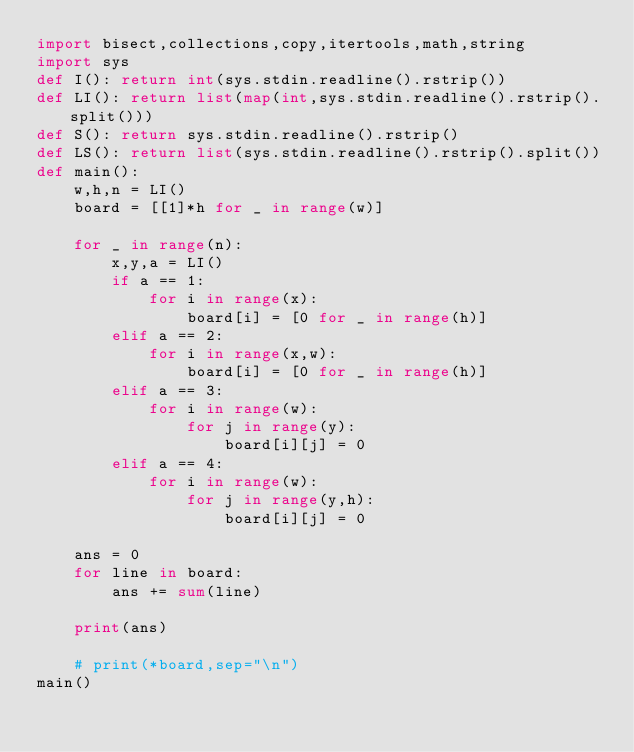<code> <loc_0><loc_0><loc_500><loc_500><_Python_>import bisect,collections,copy,itertools,math,string
import sys
def I(): return int(sys.stdin.readline().rstrip())
def LI(): return list(map(int,sys.stdin.readline().rstrip().split()))
def S(): return sys.stdin.readline().rstrip()
def LS(): return list(sys.stdin.readline().rstrip().split())
def main():
    w,h,n = LI()
    board = [[1]*h for _ in range(w)]

    for _ in range(n):
        x,y,a = LI()
        if a == 1:
            for i in range(x):
                board[i] = [0 for _ in range(h)]
        elif a == 2:
            for i in range(x,w):
                board[i] = [0 for _ in range(h)]
        elif a == 3:
            for i in range(w):
                for j in range(y):
                    board[i][j] = 0
        elif a == 4:
            for i in range(w):
                for j in range(y,h):
                    board[i][j] = 0

    ans = 0
    for line in board:
        ans += sum(line)

    print(ans)

    # print(*board,sep="\n")
main()            
</code> 